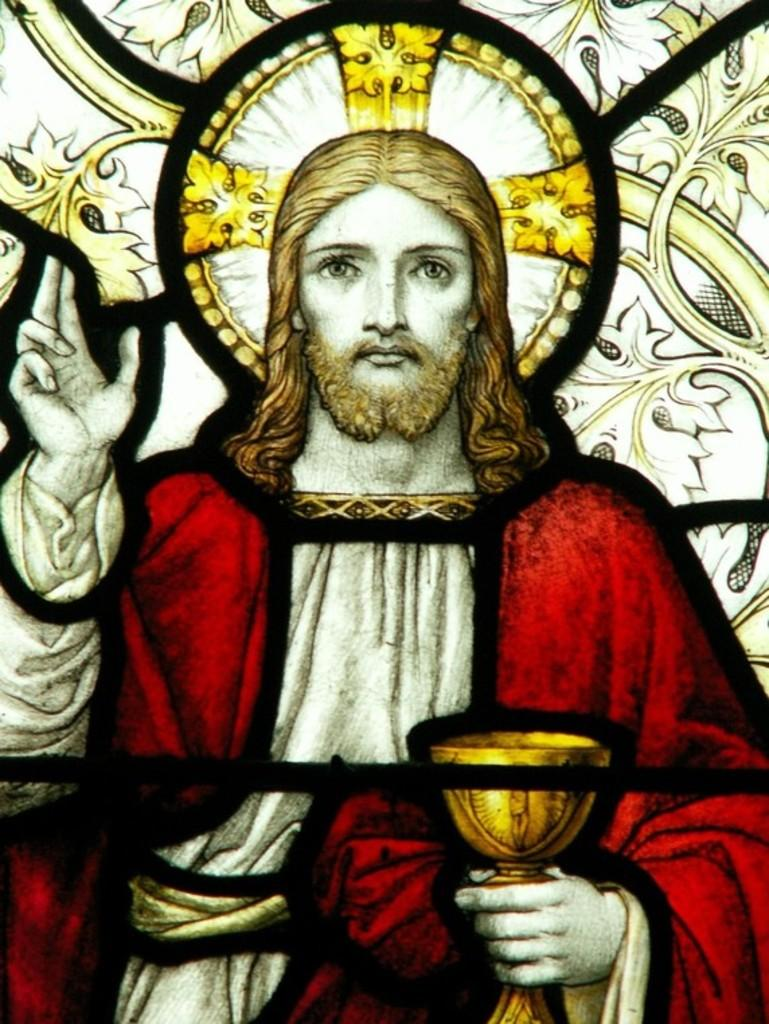What type of glass is depicted in the image? There is stained glass in the image. What design can be seen on the stained glass? The stained glass has a design of a person on it. How many hens are visible in the image? There are no hens present in the image; it features stained glass with a design of a person. What type of ice can be seen melting on the stained glass? There is no ice present in the image; it features stained glass with a person's design. 